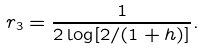<formula> <loc_0><loc_0><loc_500><loc_500>r _ { 3 } = \frac { 1 } { 2 \log [ 2 / ( 1 + h ) ] } .</formula> 